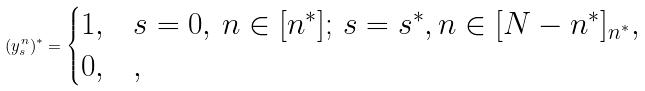<formula> <loc_0><loc_0><loc_500><loc_500>( y ^ { n } _ { s } ) ^ { * } = \begin{cases} 1 , & s = 0 , \, n \in [ n ^ { * } ] ; \, s = s ^ { * } , n \in [ N - n ^ { * } ] _ { n ^ { * } } , \\ 0 , & , \end{cases}</formula> 